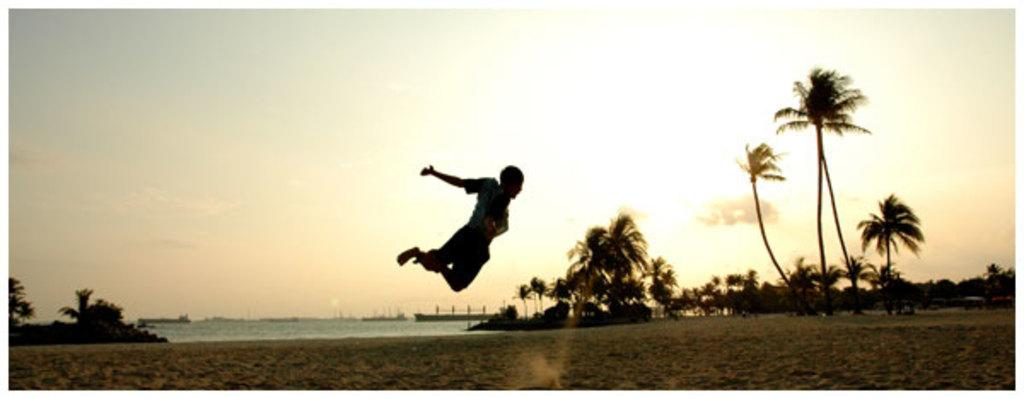Who or what is the main subject in the image? There is a person in the image. What is the person doing in the image? The person is jumping. What can be seen in the background of the image? There is water, trees, and the sky visible in the background of the image. What type of representative is required to join the person in the image? There is no indication in the image that the person needs a representative to join them, as the image only shows a person jumping. 